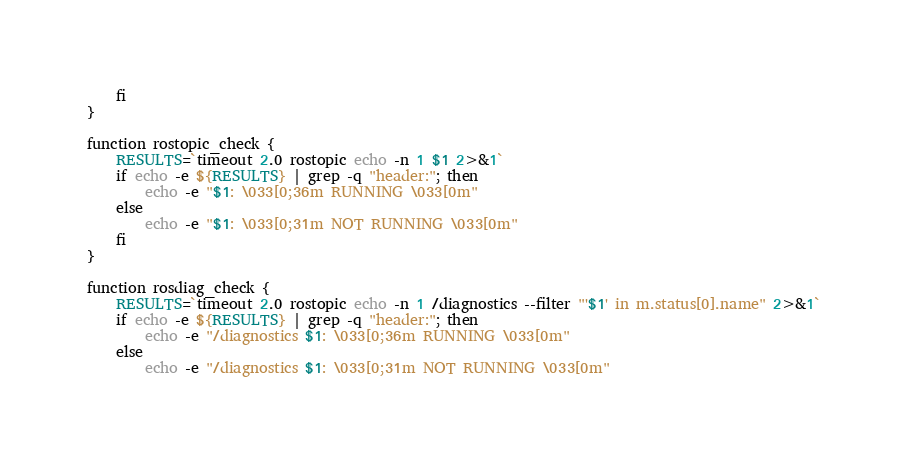<code> <loc_0><loc_0><loc_500><loc_500><_Bash_>    fi
}

function rostopic_check {
    RESULTS=`timeout 2.0 rostopic echo -n 1 $1 2>&1`
    if echo -e ${RESULTS} | grep -q "header:"; then
        echo -e "$1: \033[0;36m RUNNING \033[0m"
    else
        echo -e "$1: \033[0;31m NOT RUNNING \033[0m"
    fi
}

function rosdiag_check {
    RESULTS=`timeout 2.0 rostopic echo -n 1 /diagnostics --filter "'$1' in m.status[0].name" 2>&1`
    if echo -e ${RESULTS} | grep -q "header:"; then
        echo -e "/diagnostics $1: \033[0;36m RUNNING \033[0m"
    else
        echo -e "/diagnostics $1: \033[0;31m NOT RUNNING \033[0m"</code> 